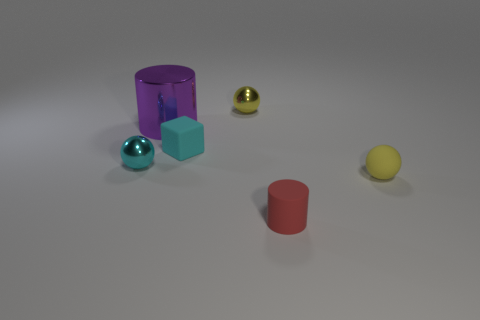Subtract all tiny matte spheres. How many spheres are left? 2 Add 1 rubber cylinders. How many objects exist? 7 Subtract all blue cylinders. Subtract all green cubes. How many cylinders are left? 2 Subtract all red cylinders. How many yellow balls are left? 2 Subtract all matte spheres. Subtract all matte spheres. How many objects are left? 4 Add 1 rubber cylinders. How many rubber cylinders are left? 2 Add 4 gray matte spheres. How many gray matte spheres exist? 4 Subtract all red cylinders. How many cylinders are left? 1 Subtract 0 purple spheres. How many objects are left? 6 Subtract all cylinders. How many objects are left? 4 